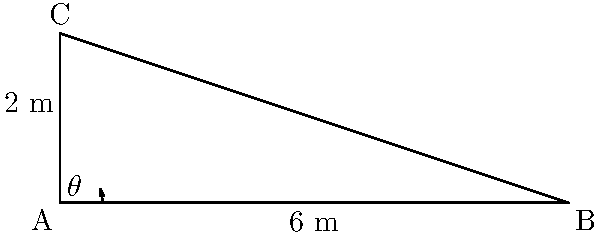A relief supply truck needs to be loaded using a ramp. The truck's cargo area is 2 meters high, and due to space constraints, the ramp can only extend 6 meters horizontally. What is the optimal angle $\theta$ (in degrees, rounded to one decimal place) at which the ramp should be positioned for easy loading of supplies? To find the optimal angle $\theta$ for the ramp, we can use the inverse tangent function (arctangent or $\tan^{-1}$). Here's how to solve this step-by-step:

1) In this right-angled triangle:
   - The opposite side (height of the truck) is 2 meters
   - The adjacent side (horizontal extension of the ramp) is 6 meters

2) The tangent of an angle is defined as the ratio of the opposite side to the adjacent side:

   $\tan(\theta) = \frac{\text{opposite}}{\text{adjacent}} = \frac{2}{6} = \frac{1}{3}$

3) To find $\theta$, we need to take the inverse tangent (arctangent) of this ratio:

   $\theta = \tan^{-1}(\frac{1}{3})$

4) Using a calculator or computational tool:

   $\theta \approx 18.4349...$

5) Rounding to one decimal place:

   $\theta \approx 18.4°$

Therefore, the optimal angle for positioning the ramp is approximately 18.4 degrees.
Answer: $18.4°$ 